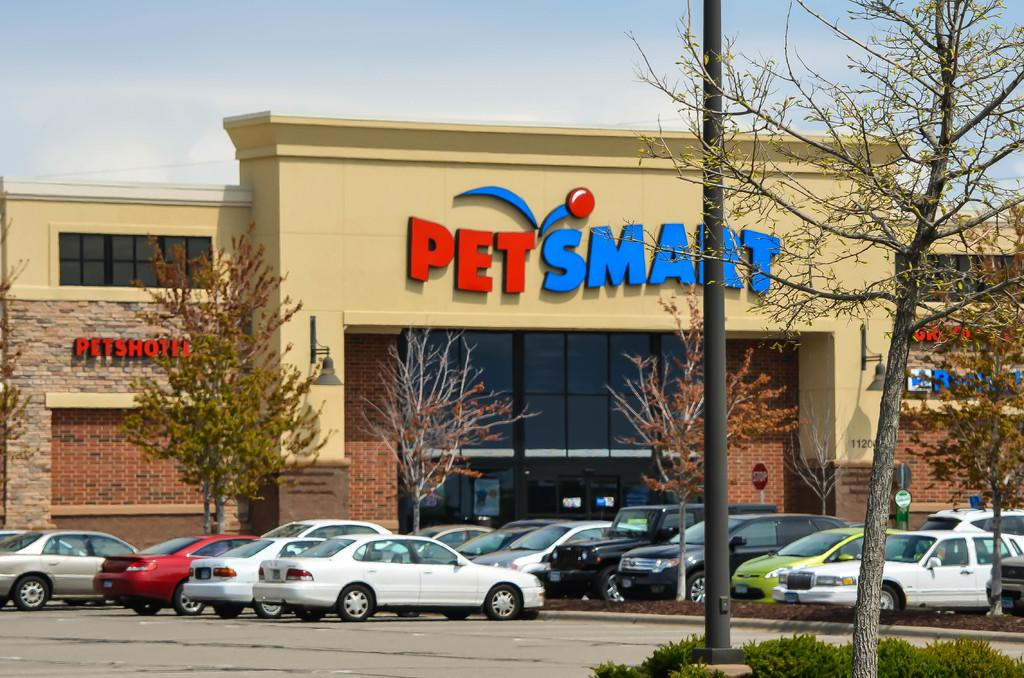What type of building is shown in the image? The image appears to depict a store building. What can be seen in front of the building? There are cars parked in front of the building. What type of vegetation is visible at the top of the image? Trees are visible at the top of the image. What is visible in the background of the image? The sky is visible at the top of the image. What type of yoke is being used by the manager in the image? There is no manager or yoke present in the image. 